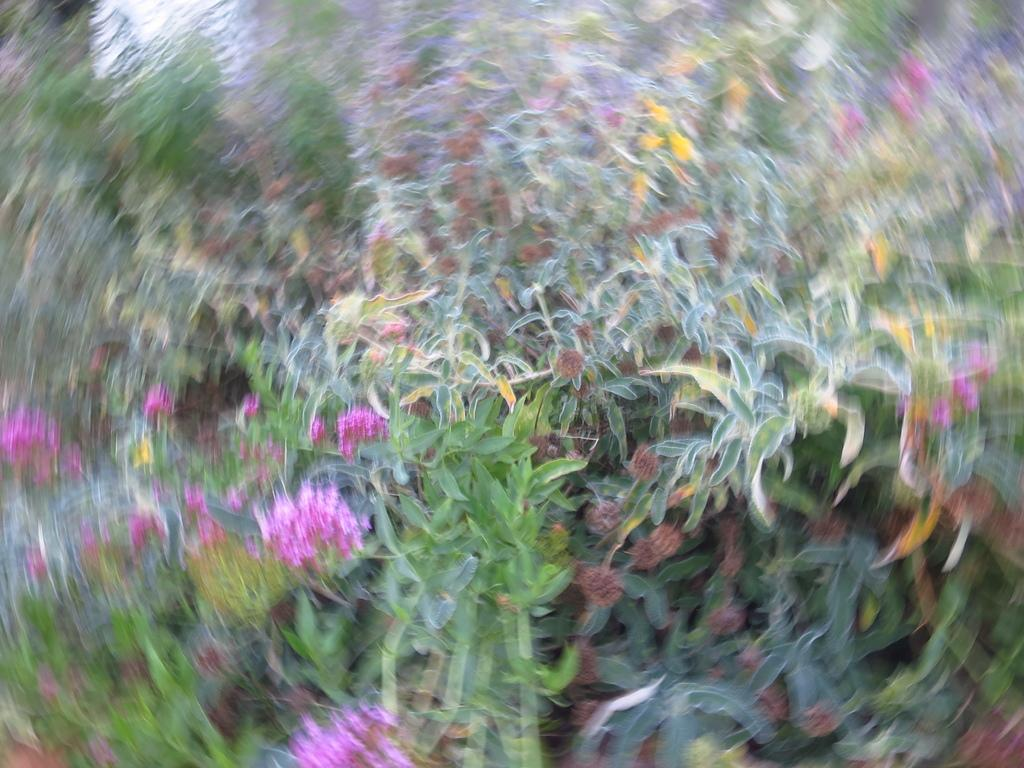What type of living organisms can be seen in the image? Plants and flowers are visible in the image. Can you describe the specific flora in the image? The image contains plants and flowers, but the blurred quality makes it difficult to identify specific types. What type of soup is being served in the image? There is no soup present in the image; it features plants and flowers. Can you describe the color of the sock in the image? There is no sock present in the image. 